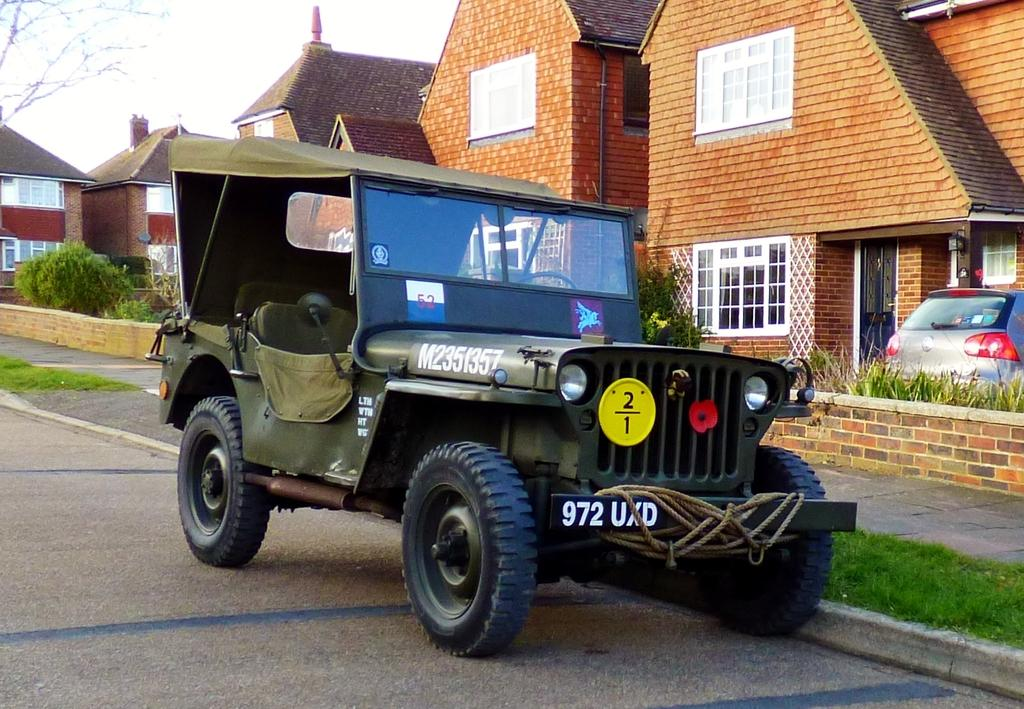What is parked on the path in the image? There is a vehicle parked on the path in the image. What type of structures can be seen in the image? Roofs of houses are visible in the image. What type of vehicle is present in the image? There is a car in the image. What type of vegetation is present in the image? Plants and grass are visible in the image. Where is the tree located in the image? There is a tree on the left side of the image. What is visible in the background of the image? The sky is visible in the image. What type of butter can be seen melting on the crack in the image? There is no butter or crack present in the image. What type of line is visible on the tree in the image? There is no line visible on the tree in the image. 